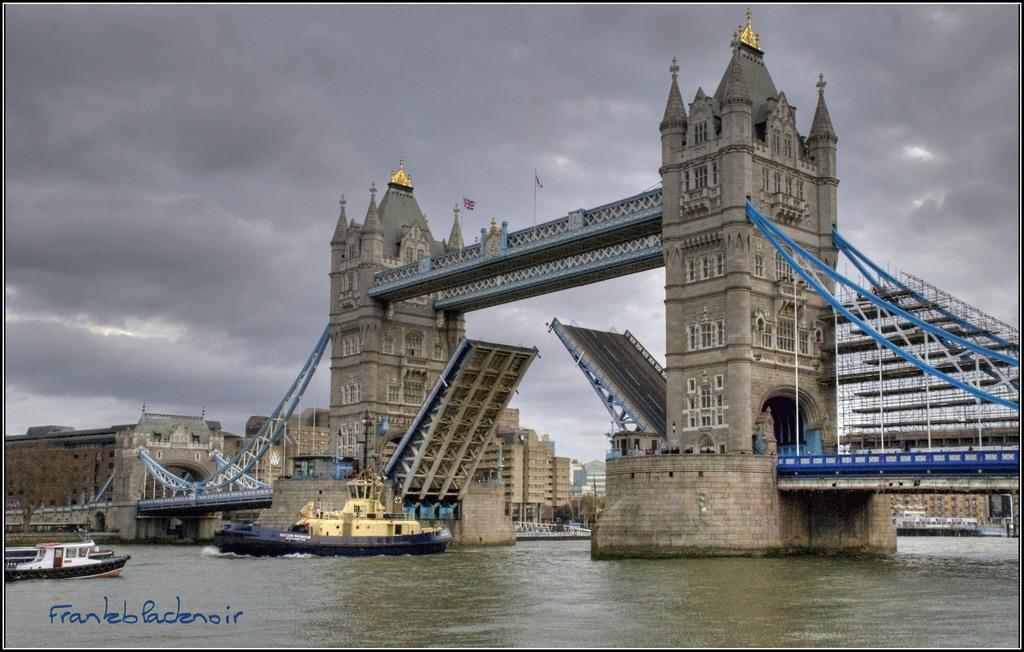What type of structures can be seen in the image? There are buildings in the image. What architectural feature is visible on the buildings? Windows are visible in the image. What type of transportation infrastructure is present in the image? There is a bridge in the image. What is visible in the sky in the image? The sky is visible in the image. What type of vehicles can be seen on the water surface in the image? There are ships on the water surface in the image. How does the seed balance itself on the bridge in the image? There is no seed present in the image, and therefore no such activity can be observed. What type of interest can be seen on the ships in the image? There is no indication of interest in the image; it simply shows ships on the water surface. 